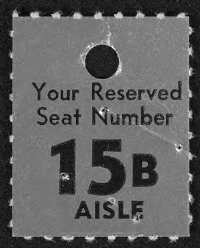What is the Reserved Seat Number given?
Keep it short and to the point. 15B Aisle. 